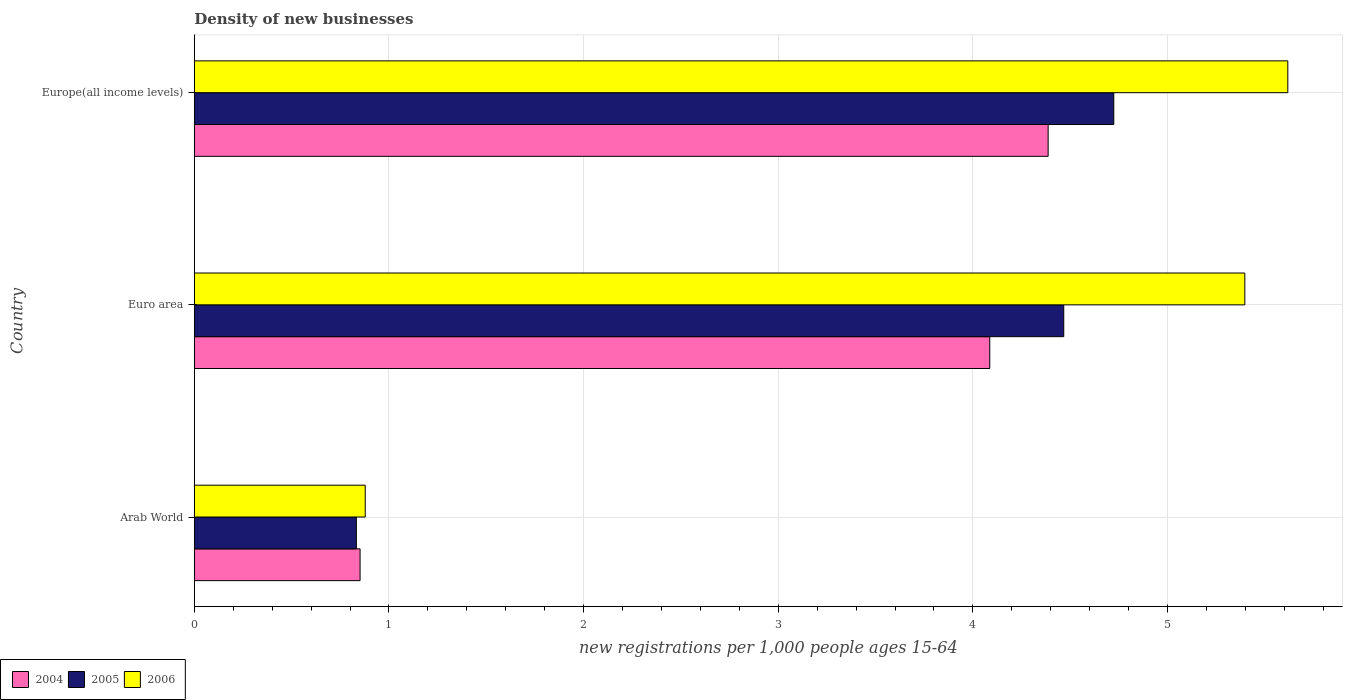How many groups of bars are there?
Your answer should be compact. 3. Are the number of bars on each tick of the Y-axis equal?
Your answer should be very brief. Yes. What is the number of new registrations in 2005 in Europe(all income levels)?
Your answer should be very brief. 4.72. Across all countries, what is the maximum number of new registrations in 2005?
Provide a short and direct response. 4.72. Across all countries, what is the minimum number of new registrations in 2005?
Ensure brevity in your answer.  0.83. In which country was the number of new registrations in 2006 maximum?
Offer a very short reply. Europe(all income levels). In which country was the number of new registrations in 2004 minimum?
Offer a very short reply. Arab World. What is the total number of new registrations in 2004 in the graph?
Make the answer very short. 9.32. What is the difference between the number of new registrations in 2004 in Euro area and that in Europe(all income levels)?
Your response must be concise. -0.3. What is the difference between the number of new registrations in 2004 in Euro area and the number of new registrations in 2005 in Arab World?
Offer a very short reply. 3.25. What is the average number of new registrations in 2005 per country?
Provide a succinct answer. 3.34. What is the difference between the number of new registrations in 2005 and number of new registrations in 2004 in Arab World?
Provide a short and direct response. -0.02. What is the ratio of the number of new registrations in 2006 in Euro area to that in Europe(all income levels)?
Keep it short and to the point. 0.96. Is the number of new registrations in 2006 in Arab World less than that in Europe(all income levels)?
Provide a succinct answer. Yes. Is the difference between the number of new registrations in 2005 in Euro area and Europe(all income levels) greater than the difference between the number of new registrations in 2004 in Euro area and Europe(all income levels)?
Give a very brief answer. Yes. What is the difference between the highest and the second highest number of new registrations in 2006?
Offer a terse response. 0.22. What is the difference between the highest and the lowest number of new registrations in 2005?
Provide a short and direct response. 3.89. In how many countries, is the number of new registrations in 2005 greater than the average number of new registrations in 2005 taken over all countries?
Offer a terse response. 2. What does the 2nd bar from the bottom in Europe(all income levels) represents?
Provide a short and direct response. 2005. How many bars are there?
Offer a terse response. 9. Are the values on the major ticks of X-axis written in scientific E-notation?
Your response must be concise. No. How many legend labels are there?
Your answer should be very brief. 3. What is the title of the graph?
Offer a terse response. Density of new businesses. What is the label or title of the X-axis?
Offer a very short reply. New registrations per 1,0 people ages 15-64. What is the label or title of the Y-axis?
Offer a very short reply. Country. What is the new registrations per 1,000 people ages 15-64 of 2004 in Arab World?
Your response must be concise. 0.85. What is the new registrations per 1,000 people ages 15-64 in 2005 in Arab World?
Keep it short and to the point. 0.83. What is the new registrations per 1,000 people ages 15-64 in 2006 in Arab World?
Offer a very short reply. 0.88. What is the new registrations per 1,000 people ages 15-64 in 2004 in Euro area?
Keep it short and to the point. 4.09. What is the new registrations per 1,000 people ages 15-64 of 2005 in Euro area?
Offer a terse response. 4.47. What is the new registrations per 1,000 people ages 15-64 of 2006 in Euro area?
Provide a succinct answer. 5.4. What is the new registrations per 1,000 people ages 15-64 of 2004 in Europe(all income levels)?
Keep it short and to the point. 4.39. What is the new registrations per 1,000 people ages 15-64 in 2005 in Europe(all income levels)?
Your answer should be compact. 4.72. What is the new registrations per 1,000 people ages 15-64 of 2006 in Europe(all income levels)?
Offer a very short reply. 5.62. Across all countries, what is the maximum new registrations per 1,000 people ages 15-64 of 2004?
Your response must be concise. 4.39. Across all countries, what is the maximum new registrations per 1,000 people ages 15-64 in 2005?
Offer a very short reply. 4.72. Across all countries, what is the maximum new registrations per 1,000 people ages 15-64 in 2006?
Offer a terse response. 5.62. Across all countries, what is the minimum new registrations per 1,000 people ages 15-64 of 2004?
Your answer should be very brief. 0.85. Across all countries, what is the minimum new registrations per 1,000 people ages 15-64 of 2005?
Offer a very short reply. 0.83. Across all countries, what is the minimum new registrations per 1,000 people ages 15-64 of 2006?
Ensure brevity in your answer.  0.88. What is the total new registrations per 1,000 people ages 15-64 in 2004 in the graph?
Your answer should be very brief. 9.32. What is the total new registrations per 1,000 people ages 15-64 of 2005 in the graph?
Your answer should be very brief. 10.02. What is the total new registrations per 1,000 people ages 15-64 of 2006 in the graph?
Provide a short and direct response. 11.89. What is the difference between the new registrations per 1,000 people ages 15-64 of 2004 in Arab World and that in Euro area?
Offer a very short reply. -3.23. What is the difference between the new registrations per 1,000 people ages 15-64 of 2005 in Arab World and that in Euro area?
Make the answer very short. -3.63. What is the difference between the new registrations per 1,000 people ages 15-64 in 2006 in Arab World and that in Euro area?
Your answer should be compact. -4.52. What is the difference between the new registrations per 1,000 people ages 15-64 of 2004 in Arab World and that in Europe(all income levels)?
Keep it short and to the point. -3.53. What is the difference between the new registrations per 1,000 people ages 15-64 in 2005 in Arab World and that in Europe(all income levels)?
Your response must be concise. -3.89. What is the difference between the new registrations per 1,000 people ages 15-64 of 2006 in Arab World and that in Europe(all income levels)?
Give a very brief answer. -4.74. What is the difference between the new registrations per 1,000 people ages 15-64 in 2004 in Euro area and that in Europe(all income levels)?
Your answer should be compact. -0.3. What is the difference between the new registrations per 1,000 people ages 15-64 in 2005 in Euro area and that in Europe(all income levels)?
Give a very brief answer. -0.26. What is the difference between the new registrations per 1,000 people ages 15-64 in 2006 in Euro area and that in Europe(all income levels)?
Your answer should be compact. -0.22. What is the difference between the new registrations per 1,000 people ages 15-64 in 2004 in Arab World and the new registrations per 1,000 people ages 15-64 in 2005 in Euro area?
Provide a succinct answer. -3.61. What is the difference between the new registrations per 1,000 people ages 15-64 in 2004 in Arab World and the new registrations per 1,000 people ages 15-64 in 2006 in Euro area?
Provide a short and direct response. -4.54. What is the difference between the new registrations per 1,000 people ages 15-64 in 2005 in Arab World and the new registrations per 1,000 people ages 15-64 in 2006 in Euro area?
Offer a terse response. -4.56. What is the difference between the new registrations per 1,000 people ages 15-64 in 2004 in Arab World and the new registrations per 1,000 people ages 15-64 in 2005 in Europe(all income levels)?
Ensure brevity in your answer.  -3.87. What is the difference between the new registrations per 1,000 people ages 15-64 of 2004 in Arab World and the new registrations per 1,000 people ages 15-64 of 2006 in Europe(all income levels)?
Provide a short and direct response. -4.77. What is the difference between the new registrations per 1,000 people ages 15-64 of 2005 in Arab World and the new registrations per 1,000 people ages 15-64 of 2006 in Europe(all income levels)?
Provide a succinct answer. -4.79. What is the difference between the new registrations per 1,000 people ages 15-64 of 2004 in Euro area and the new registrations per 1,000 people ages 15-64 of 2005 in Europe(all income levels)?
Your response must be concise. -0.64. What is the difference between the new registrations per 1,000 people ages 15-64 of 2004 in Euro area and the new registrations per 1,000 people ages 15-64 of 2006 in Europe(all income levels)?
Make the answer very short. -1.53. What is the difference between the new registrations per 1,000 people ages 15-64 of 2005 in Euro area and the new registrations per 1,000 people ages 15-64 of 2006 in Europe(all income levels)?
Give a very brief answer. -1.15. What is the average new registrations per 1,000 people ages 15-64 in 2004 per country?
Provide a succinct answer. 3.11. What is the average new registrations per 1,000 people ages 15-64 in 2005 per country?
Provide a short and direct response. 3.34. What is the average new registrations per 1,000 people ages 15-64 of 2006 per country?
Provide a succinct answer. 3.96. What is the difference between the new registrations per 1,000 people ages 15-64 in 2004 and new registrations per 1,000 people ages 15-64 in 2005 in Arab World?
Your answer should be compact. 0.02. What is the difference between the new registrations per 1,000 people ages 15-64 of 2004 and new registrations per 1,000 people ages 15-64 of 2006 in Arab World?
Provide a succinct answer. -0.03. What is the difference between the new registrations per 1,000 people ages 15-64 in 2005 and new registrations per 1,000 people ages 15-64 in 2006 in Arab World?
Ensure brevity in your answer.  -0.05. What is the difference between the new registrations per 1,000 people ages 15-64 in 2004 and new registrations per 1,000 people ages 15-64 in 2005 in Euro area?
Your answer should be compact. -0.38. What is the difference between the new registrations per 1,000 people ages 15-64 of 2004 and new registrations per 1,000 people ages 15-64 of 2006 in Euro area?
Your answer should be very brief. -1.31. What is the difference between the new registrations per 1,000 people ages 15-64 in 2005 and new registrations per 1,000 people ages 15-64 in 2006 in Euro area?
Your answer should be compact. -0.93. What is the difference between the new registrations per 1,000 people ages 15-64 in 2004 and new registrations per 1,000 people ages 15-64 in 2005 in Europe(all income levels)?
Your answer should be compact. -0.34. What is the difference between the new registrations per 1,000 people ages 15-64 of 2004 and new registrations per 1,000 people ages 15-64 of 2006 in Europe(all income levels)?
Provide a succinct answer. -1.23. What is the difference between the new registrations per 1,000 people ages 15-64 in 2005 and new registrations per 1,000 people ages 15-64 in 2006 in Europe(all income levels)?
Provide a short and direct response. -0.89. What is the ratio of the new registrations per 1,000 people ages 15-64 in 2004 in Arab World to that in Euro area?
Keep it short and to the point. 0.21. What is the ratio of the new registrations per 1,000 people ages 15-64 of 2005 in Arab World to that in Euro area?
Give a very brief answer. 0.19. What is the ratio of the new registrations per 1,000 people ages 15-64 of 2006 in Arab World to that in Euro area?
Your answer should be very brief. 0.16. What is the ratio of the new registrations per 1,000 people ages 15-64 of 2004 in Arab World to that in Europe(all income levels)?
Your answer should be compact. 0.19. What is the ratio of the new registrations per 1,000 people ages 15-64 in 2005 in Arab World to that in Europe(all income levels)?
Ensure brevity in your answer.  0.18. What is the ratio of the new registrations per 1,000 people ages 15-64 in 2006 in Arab World to that in Europe(all income levels)?
Provide a succinct answer. 0.16. What is the ratio of the new registrations per 1,000 people ages 15-64 of 2004 in Euro area to that in Europe(all income levels)?
Make the answer very short. 0.93. What is the ratio of the new registrations per 1,000 people ages 15-64 of 2005 in Euro area to that in Europe(all income levels)?
Your answer should be very brief. 0.95. What is the ratio of the new registrations per 1,000 people ages 15-64 in 2006 in Euro area to that in Europe(all income levels)?
Ensure brevity in your answer.  0.96. What is the difference between the highest and the second highest new registrations per 1,000 people ages 15-64 in 2004?
Your answer should be compact. 0.3. What is the difference between the highest and the second highest new registrations per 1,000 people ages 15-64 in 2005?
Your answer should be compact. 0.26. What is the difference between the highest and the second highest new registrations per 1,000 people ages 15-64 in 2006?
Offer a terse response. 0.22. What is the difference between the highest and the lowest new registrations per 1,000 people ages 15-64 of 2004?
Your answer should be very brief. 3.53. What is the difference between the highest and the lowest new registrations per 1,000 people ages 15-64 in 2005?
Make the answer very short. 3.89. What is the difference between the highest and the lowest new registrations per 1,000 people ages 15-64 of 2006?
Your answer should be compact. 4.74. 